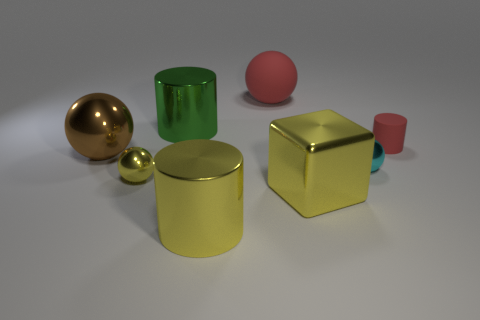Subtract all green spheres. Subtract all gray blocks. How many spheres are left? 4 Add 1 red things. How many objects exist? 9 Subtract all cylinders. How many objects are left? 5 Add 8 cyan shiny objects. How many cyan shiny objects are left? 9 Add 1 cyan cylinders. How many cyan cylinders exist? 1 Subtract 1 cyan spheres. How many objects are left? 7 Subtract all green metallic cylinders. Subtract all rubber balls. How many objects are left? 6 